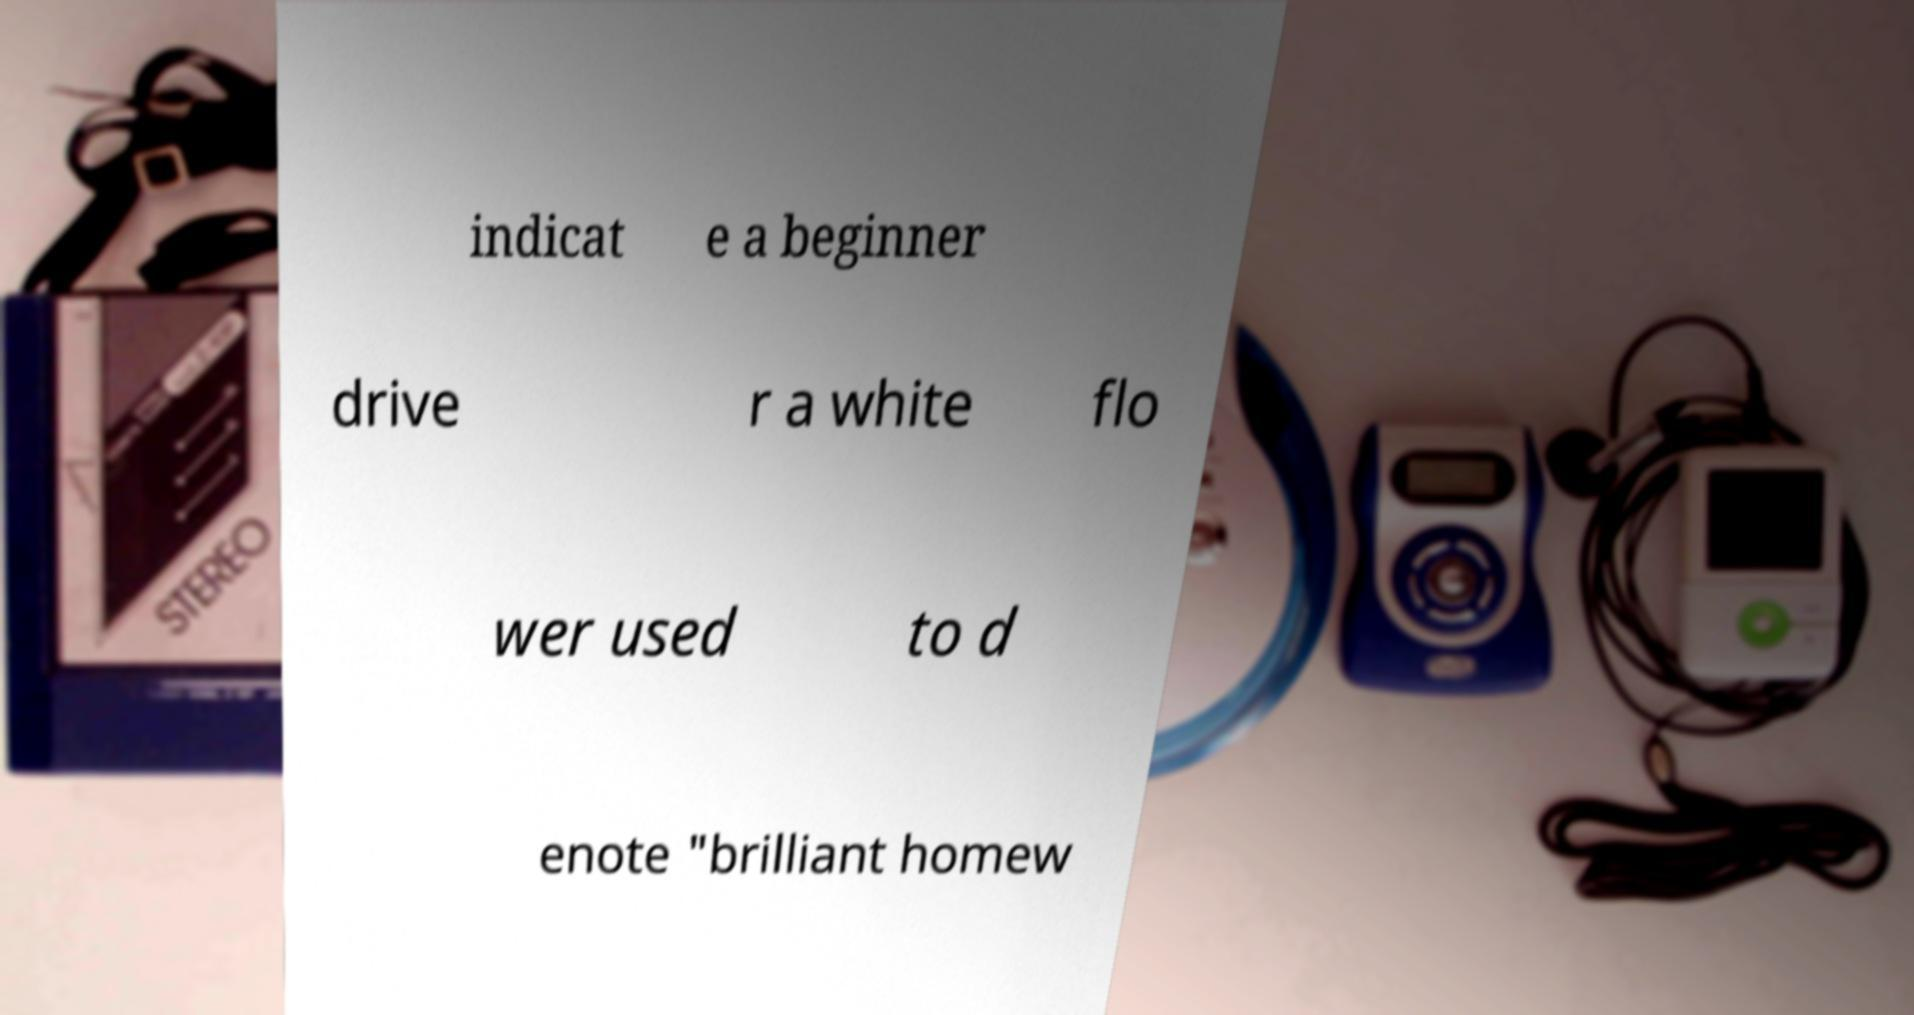For documentation purposes, I need the text within this image transcribed. Could you provide that? indicat e a beginner drive r a white flo wer used to d enote "brilliant homew 